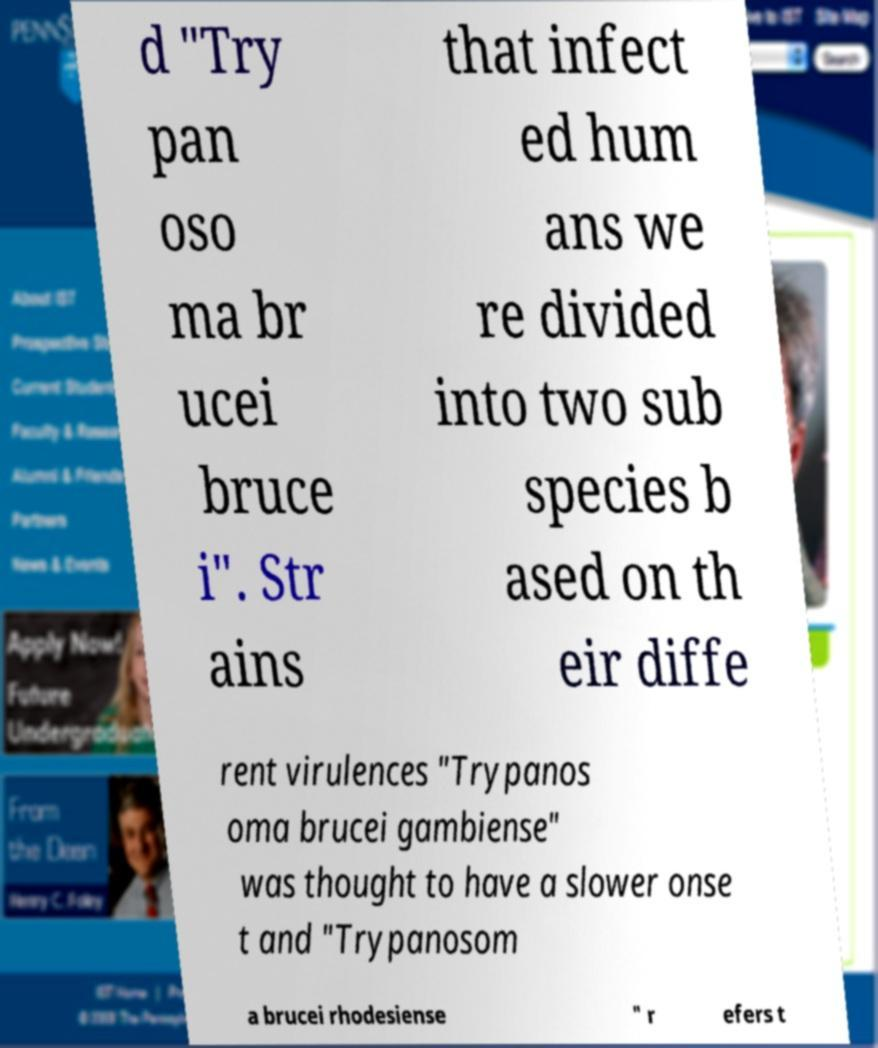Can you accurately transcribe the text from the provided image for me? d "Try pan oso ma br ucei bruce i". Str ains that infect ed hum ans we re divided into two sub species b ased on th eir diffe rent virulences "Trypanos oma brucei gambiense" was thought to have a slower onse t and "Trypanosom a brucei rhodesiense " r efers t 